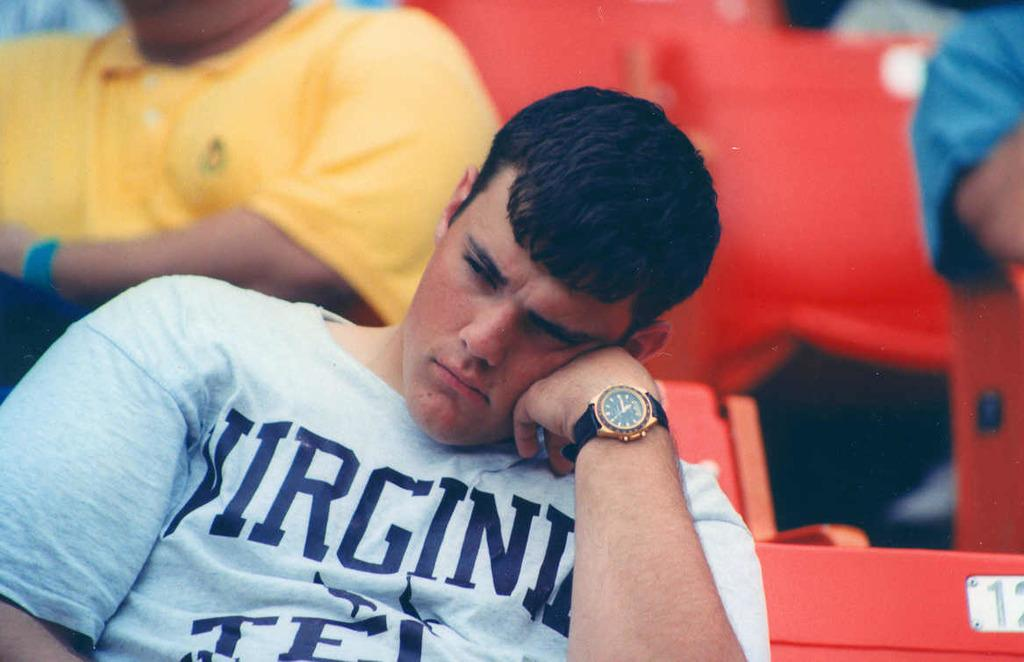<image>
Share a concise interpretation of the image provided. A man in a Virginia shirt is frowning with his head resting on his hand. 